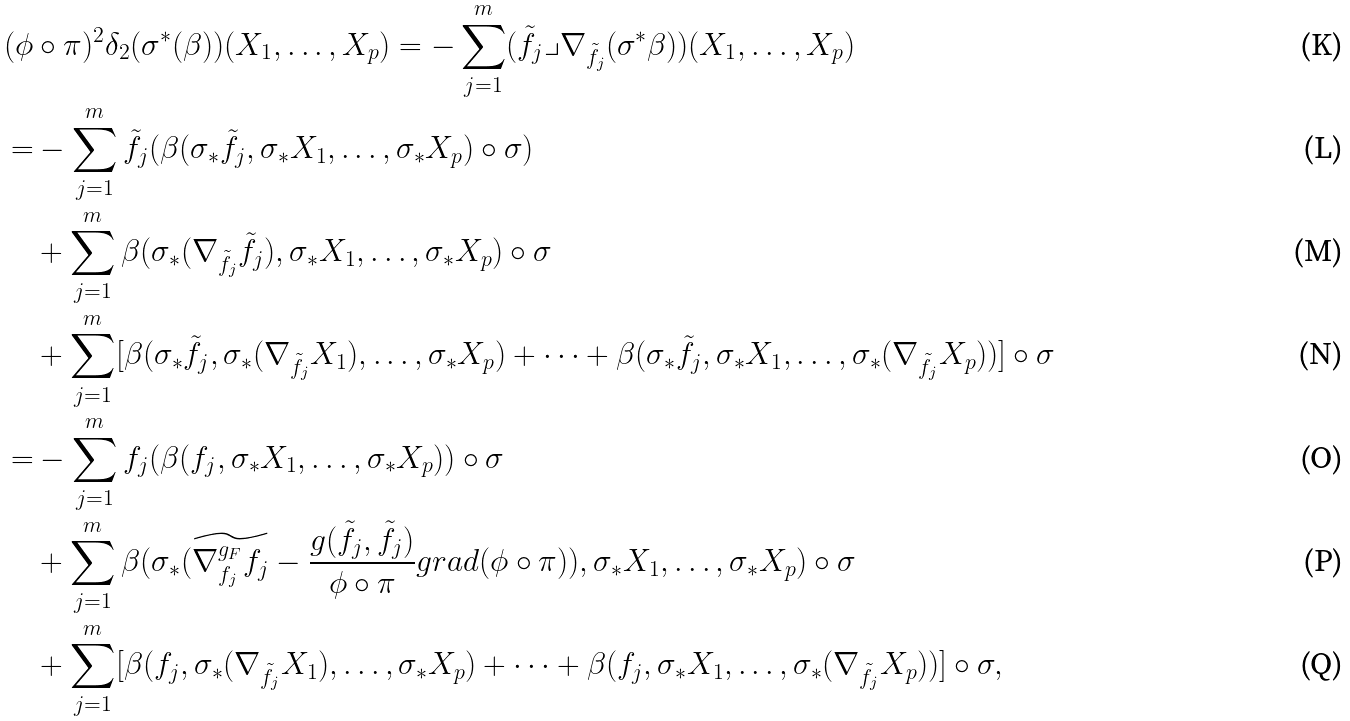Convert formula to latex. <formula><loc_0><loc_0><loc_500><loc_500>( \phi & \circ \pi ) ^ { 2 } \delta _ { 2 } ( \sigma ^ { * } ( \beta ) ) ( X _ { 1 } , \dots , X _ { p } ) = - \sum _ { j = 1 } ^ { m } ( \tilde { f _ { j } } \lrcorner \nabla _ { \tilde { f _ { j } } } ( \sigma ^ { * } \beta ) ) ( X _ { 1 } , \dots , X _ { p } ) \\ = & - \sum _ { j = 1 } ^ { m } \tilde { f _ { j } } ( \beta ( \sigma _ { * } \tilde { f _ { j } } , \sigma _ { * } X _ { 1 } , \dots , \sigma _ { * } X _ { p } ) \circ \sigma ) \\ & + \sum _ { j = 1 } ^ { m } \beta ( \sigma _ { * } ( \nabla _ { \tilde { f _ { j } } } \tilde { f _ { j } } ) , \sigma _ { * } X _ { 1 } , \dots , \sigma _ { * } X _ { p } ) \circ \sigma \\ & + \sum _ { j = 1 } ^ { m } [ \beta ( \sigma _ { * } \tilde { f _ { j } } , \sigma _ { * } ( \nabla _ { \tilde { f _ { j } } } X _ { 1 } ) , \dots , \sigma _ { * } X _ { p } ) + \cdots + \beta ( \sigma _ { * } \tilde { f _ { j } } , \sigma _ { * } X _ { 1 } , \dots , \sigma _ { * } ( \nabla _ { \tilde { f _ { j } } } X _ { p } ) ) ] \circ \sigma \\ = & - \sum _ { j = 1 } ^ { m } f _ { j } ( \beta ( f _ { j } , \sigma _ { * } X _ { 1 } , \dots , \sigma _ { * } X _ { p } ) ) \circ \sigma \\ & + \sum _ { j = 1 } ^ { m } \beta ( \sigma _ { * } ( \widetilde { \nabla ^ { g _ { F } } _ { f _ { j } } f _ { j } } - \frac { g ( \tilde { f _ { j } } , \tilde { f _ { j } } ) } { \phi \circ \pi } g r a d ( \phi \circ \pi ) ) , \sigma _ { * } X _ { 1 } , \dots , \sigma _ { * } X _ { p } ) \circ \sigma \\ & + \sum _ { j = 1 } ^ { m } [ \beta ( f _ { j } , \sigma _ { * } ( \nabla _ { \tilde { f _ { j } } } X _ { 1 } ) , \dots , \sigma _ { * } X _ { p } ) + \cdots + \beta ( f _ { j } , \sigma _ { * } X _ { 1 } , \dots , \sigma _ { * } ( \nabla _ { \tilde { f _ { j } } } X _ { p } ) ) ] \circ \sigma ,</formula> 